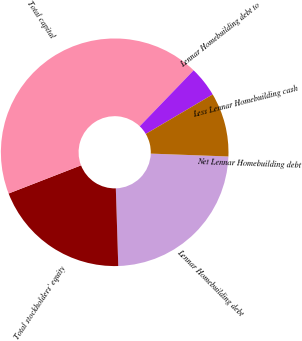Convert chart. <chart><loc_0><loc_0><loc_500><loc_500><pie_chart><fcel>Lennar Homebuilding debt<fcel>Total stockholders' equity<fcel>Total capital<fcel>Lennar Homebuilding debt to<fcel>Less Lennar Homebuilding cash<fcel>Net Lennar Homebuilding debt<nl><fcel>23.91%<fcel>19.6%<fcel>43.1%<fcel>4.31%<fcel>9.07%<fcel>0.0%<nl></chart> 